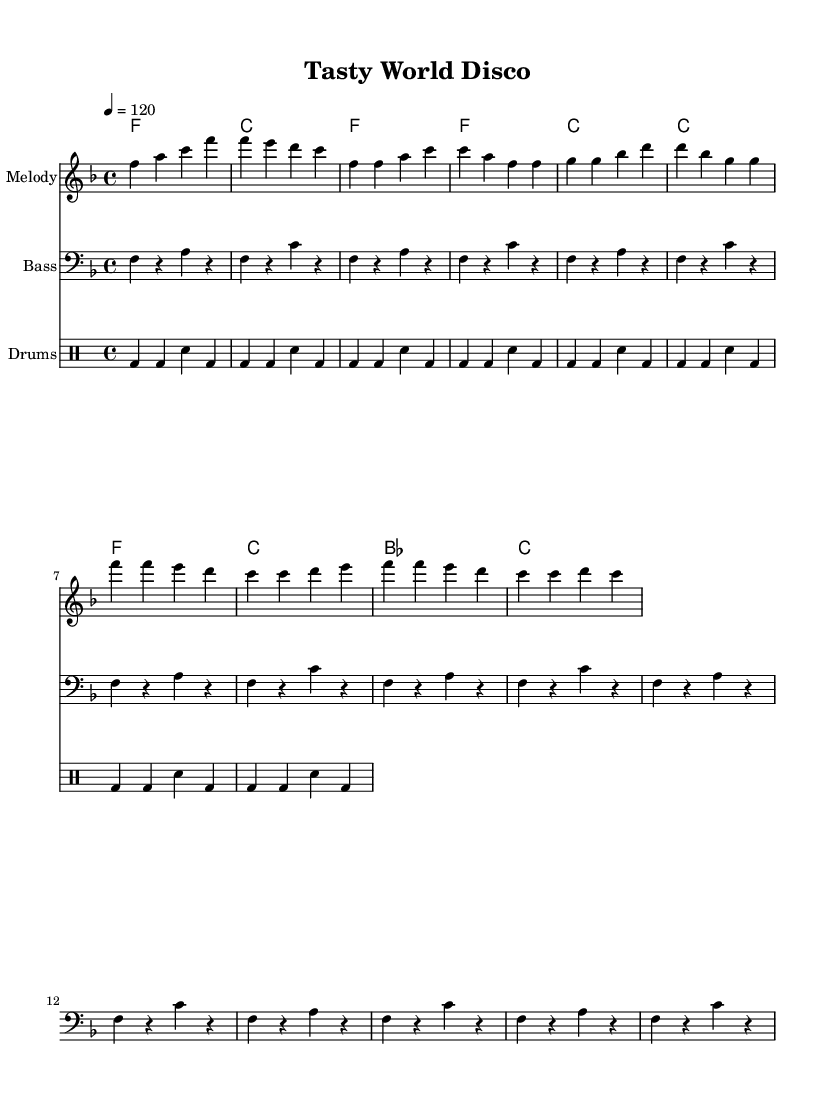What is the key signature of this music? The key signature is F major, which has one flat (B flat).
Answer: F major What is the time signature of this music? The time signature is 4/4, indicating four beats in each measure.
Answer: 4/4 What is the tempo marking for the piece? The tempo marking indicates a speed of 120 beats per minute.
Answer: 120 How many measures are in the chorus section? The chorus section consists of four measures, as indicated by the corresponding notation.
Answer: 4 What type of rhythm is predominantly used in this disco song? The predominant rhythm is a four-beat pattern, typical of disco music, characterized by a steady pulse which supports dancing and movement.
Answer: Four-beat pattern How does the melody of this disco song celebrate international cuisines? The lyrics mention "sushi" and "tacos," referencing diverse international foods which enhances cultural appreciation in music.
Answer: Sushi and tacos What instrument is used for the bass figure? The bass figure is written in the bass clef, indicating it is played by a bass instrument.
Answer: Bass 